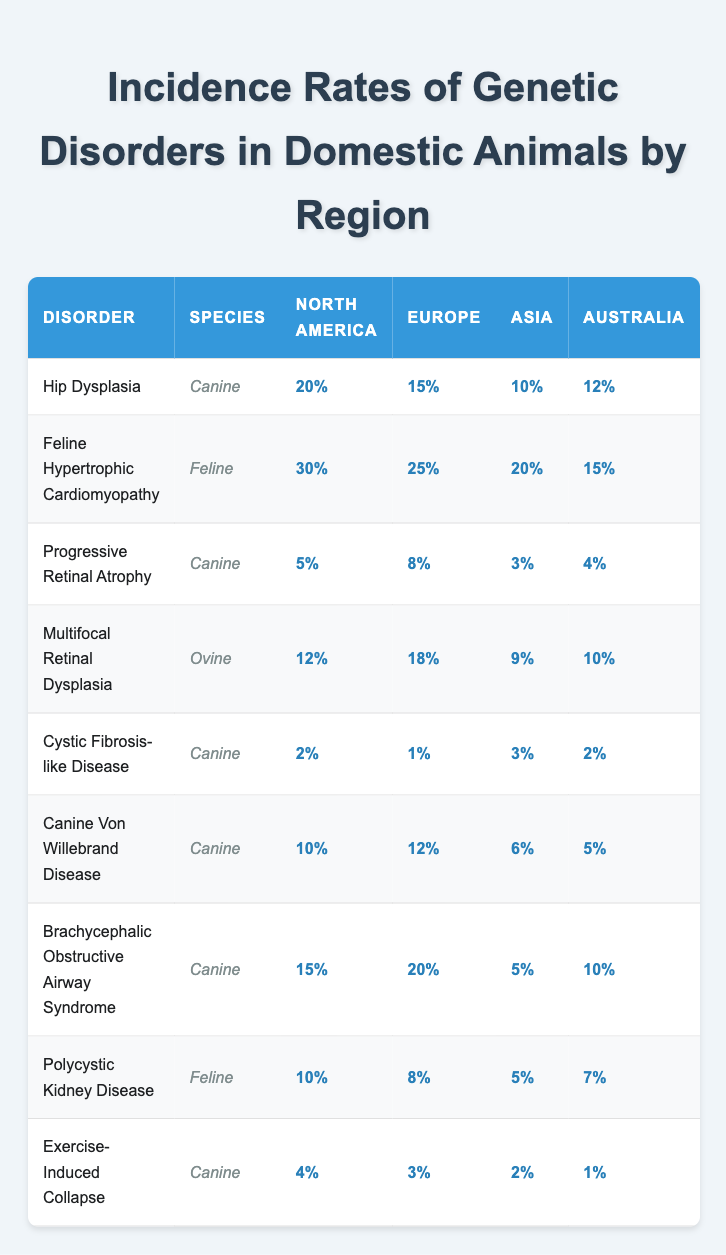What is the incidence rate of Hip Dysplasia in North America? The table shows that the incidence rate of Hip Dysplasia for Canine species in North America is listed as 20%.
Answer: 20% What is the highest incidence rate of a genetic disorder among domestic animals listed in Europe? By comparing the incidence rates in the Europe column, Feline Hypertrophic Cardiomyopathy has the highest incidence rate at 25%.
Answer: 25% Which region has the lowest incidence rate for Cystic Fibrosis-like Disease? The table indicates that the lowest incidence rate for Cystic Fibrosis-like Disease in the regions is in Europe, which is 1%.
Answer: 1% What is the average incidence rate of Progressive Retinal Atrophy across all regions? The incidence rates for Progressive Retinal Atrophy are 5% (North America), 8% (Europe), 3% (Asia), and 4% (Australia). Adding these gives 5 + 8 + 3 + 4 = 20. Dividing by 4 gives an average of 20/4 = 5%.
Answer: 5% Is the incidence rate of Brachycephalic Obstructive Airway Syndrome higher in Australia or Asia? The incidence rate in Australia is noted as 10% and in Asia as 5%. Since 10% is greater than 5%, Brachycephalic Obstructive Airway Syndrome is higher in Australia.
Answer: Yes Which species has the highest incidence rate reported for Multiscale Retinal Dysplasia in Europe? The table indicates that multifocal Retinal Dysplasia is observed in the Ovine species with an incidence rate of 18%, which is the highest for this disorder in Europe.
Answer: Ovine What is the difference in incidence rates of Canine Von Willebrand Disease between North America and Asia? The incidence rate for Canine Von Willebrand Disease is 10% in North America and 6% in Asia. The difference is 10% - 6% = 4%.
Answer: 4% What disorder has the lowest overall incidence rate in Australia? By examining the Australia column, Cystic Fibrosis-like Disease has an incidence rate of 2%, which is the lowest among all disorders.
Answer: Cystic Fibrosis-like Disease Which genetic disorder has a higher incidence rate in North America: Exercise-Induced Collapse or Progressive Retinal Atrophy? Exercise-Induced Collapse has an incidence rate of 4% in North America, whereas Progressive Retinal Atrophy has an incidence rate of 5%. Since 5% is greater than 4%, Progressive Retinal Atrophy has a higher rate.
Answer: Progressive Retinal Atrophy What is the total incidence rate of Feline Hypertrophic Cardiomyopathy across all regions? The rates are 30% (North America), 25% (Europe), 20% (Asia), and 15% (Australia). Adding these gives 30 + 25 + 20 + 15 = 90%.
Answer: 90% In which region is the incidence of Polycystic Kidney Disease lowest? Reviewing the incidence rates shows 5% for Asia, which is lower than the other regions: 10% (North America), 8% (Europe), 7% (Australia). Thus, the lowest rate is in Asia.
Answer: Asia 